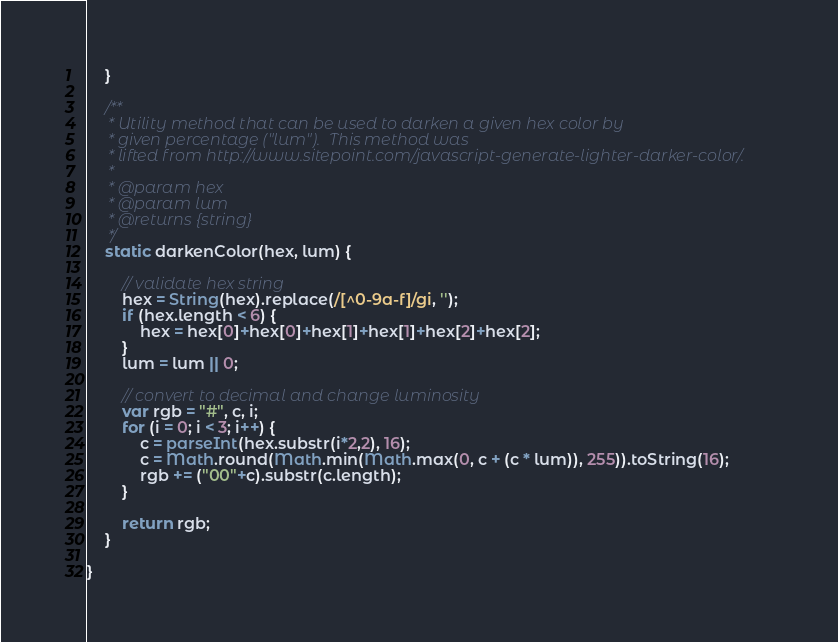Convert code to text. <code><loc_0><loc_0><loc_500><loc_500><_JavaScript_>    }

    /**
     * Utility method that can be used to darken a given hex color by
     * given percentage ("lum").  This method was
     * lifted from http://www.sitepoint.com/javascript-generate-lighter-darker-color/.
     *
     * @param hex
     * @param lum
     * @returns {string}
     */
    static darkenColor(hex, lum) {

        // validate hex string
        hex = String(hex).replace(/[^0-9a-f]/gi, '');
        if (hex.length < 6) {
            hex = hex[0]+hex[0]+hex[1]+hex[1]+hex[2]+hex[2];
        }
        lum = lum || 0;

        // convert to decimal and change luminosity
        var rgb = "#", c, i;
        for (i = 0; i < 3; i++) {
            c = parseInt(hex.substr(i*2,2), 16);
            c = Math.round(Math.min(Math.max(0, c + (c * lum)), 255)).toString(16);
            rgb += ("00"+c).substr(c.length);
        }

        return rgb;
    }

}

</code> 